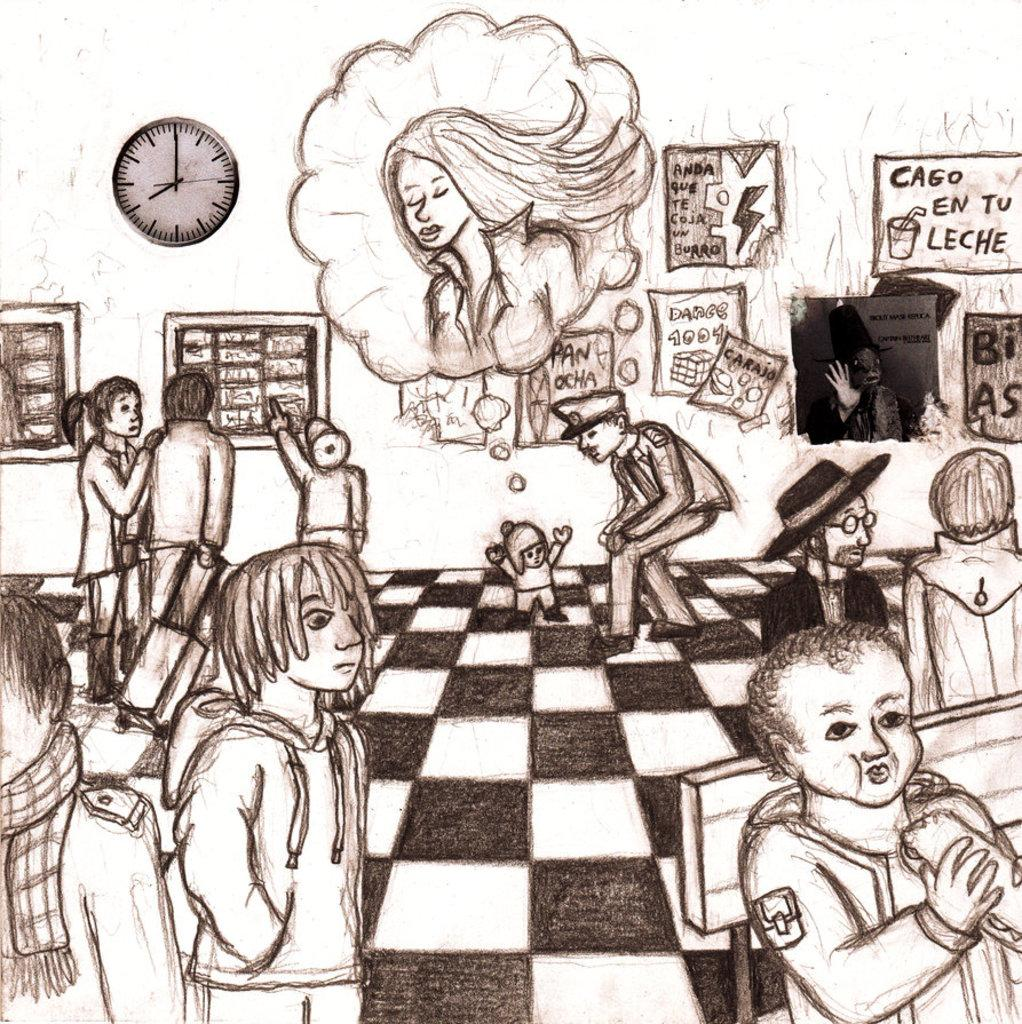<image>
Share a concise interpretation of the image provided. A black and white sketch that has a sign on the back wall that reads "Cago en tu leche" 